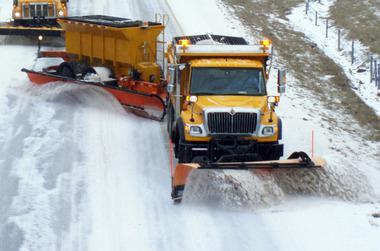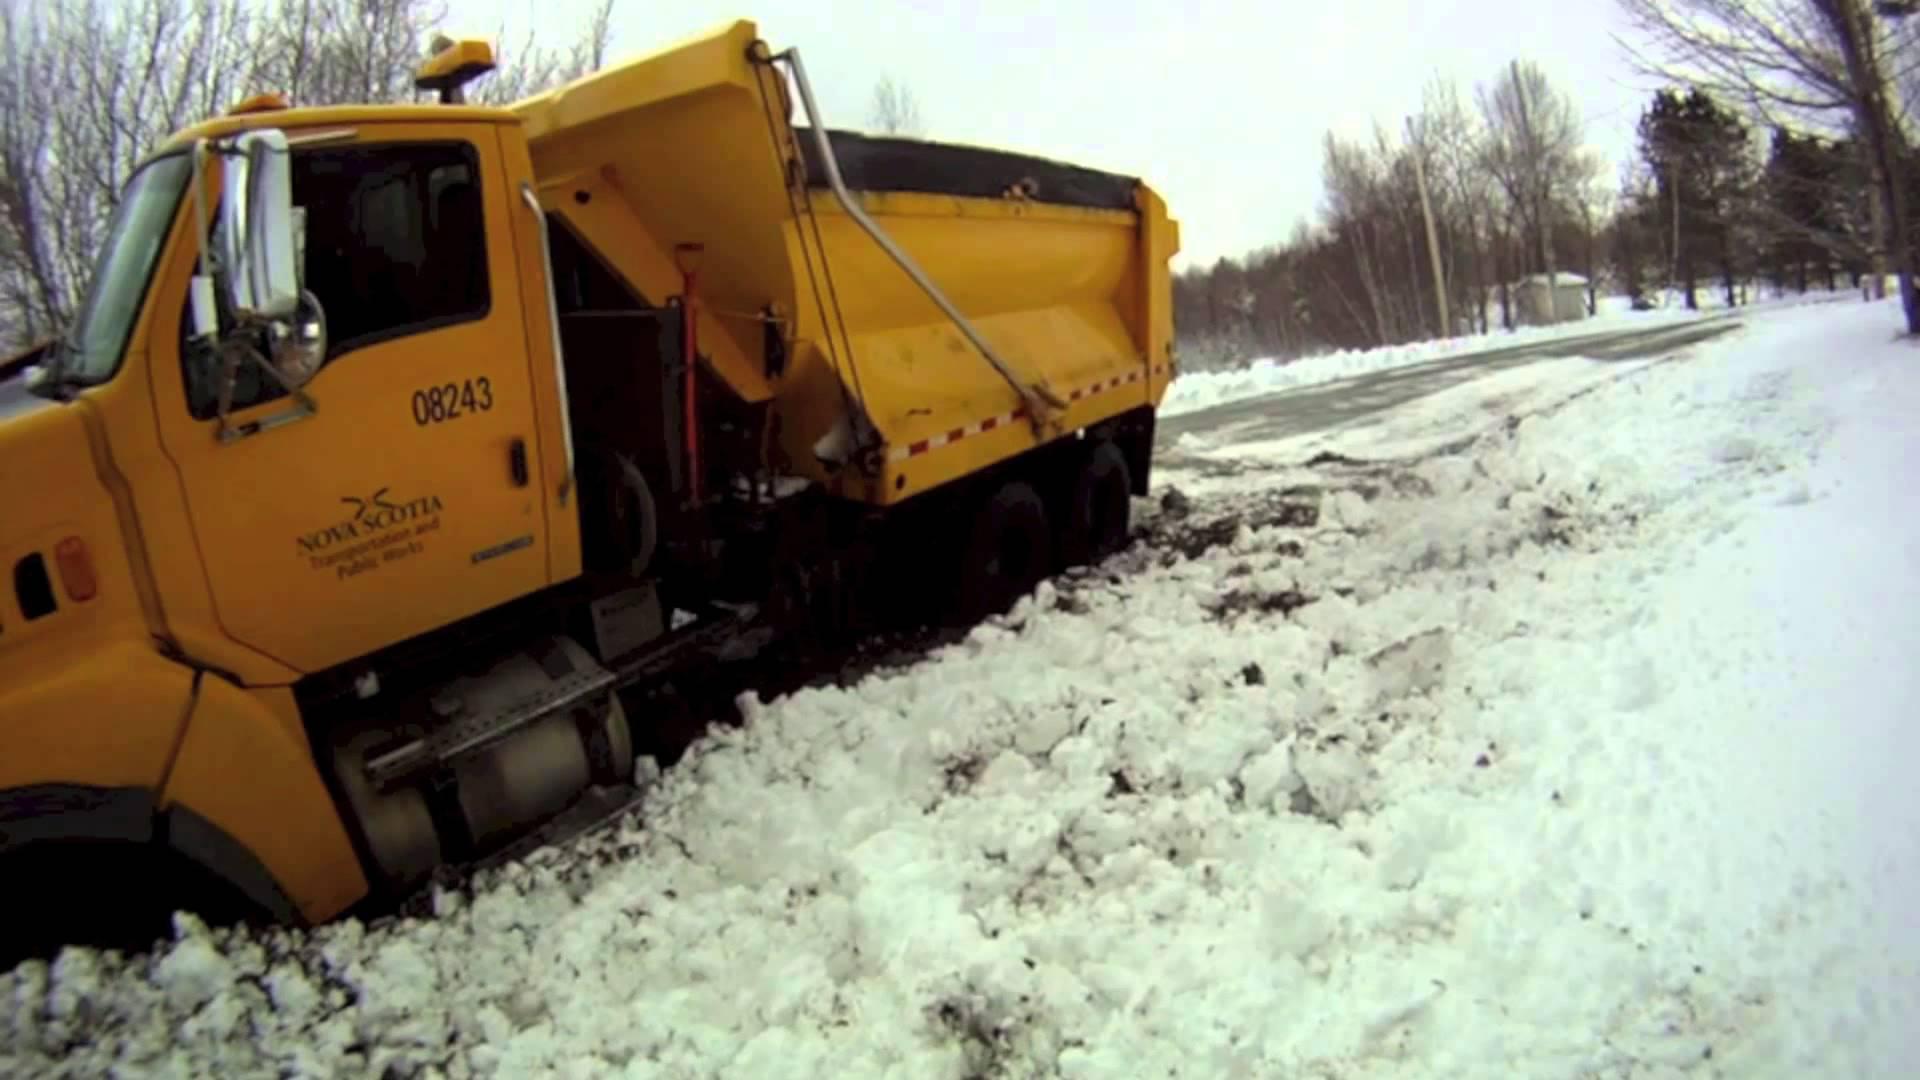The first image is the image on the left, the second image is the image on the right. For the images displayed, is the sentence "Snow cascades off of the plow in the image on the left." factually correct? Answer yes or no. Yes. 